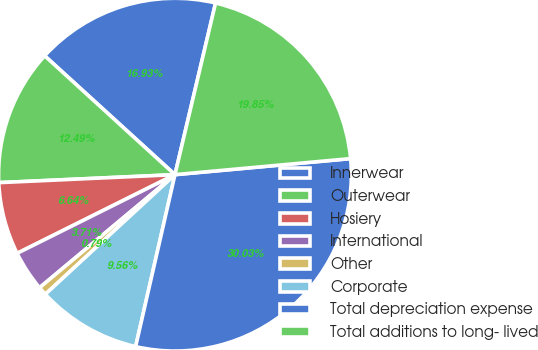Convert chart. <chart><loc_0><loc_0><loc_500><loc_500><pie_chart><fcel>Innerwear<fcel>Outerwear<fcel>Hosiery<fcel>International<fcel>Other<fcel>Corporate<fcel>Total depreciation expense<fcel>Total additions to long- lived<nl><fcel>16.93%<fcel>12.49%<fcel>6.64%<fcel>3.71%<fcel>0.79%<fcel>9.56%<fcel>30.03%<fcel>19.85%<nl></chart> 